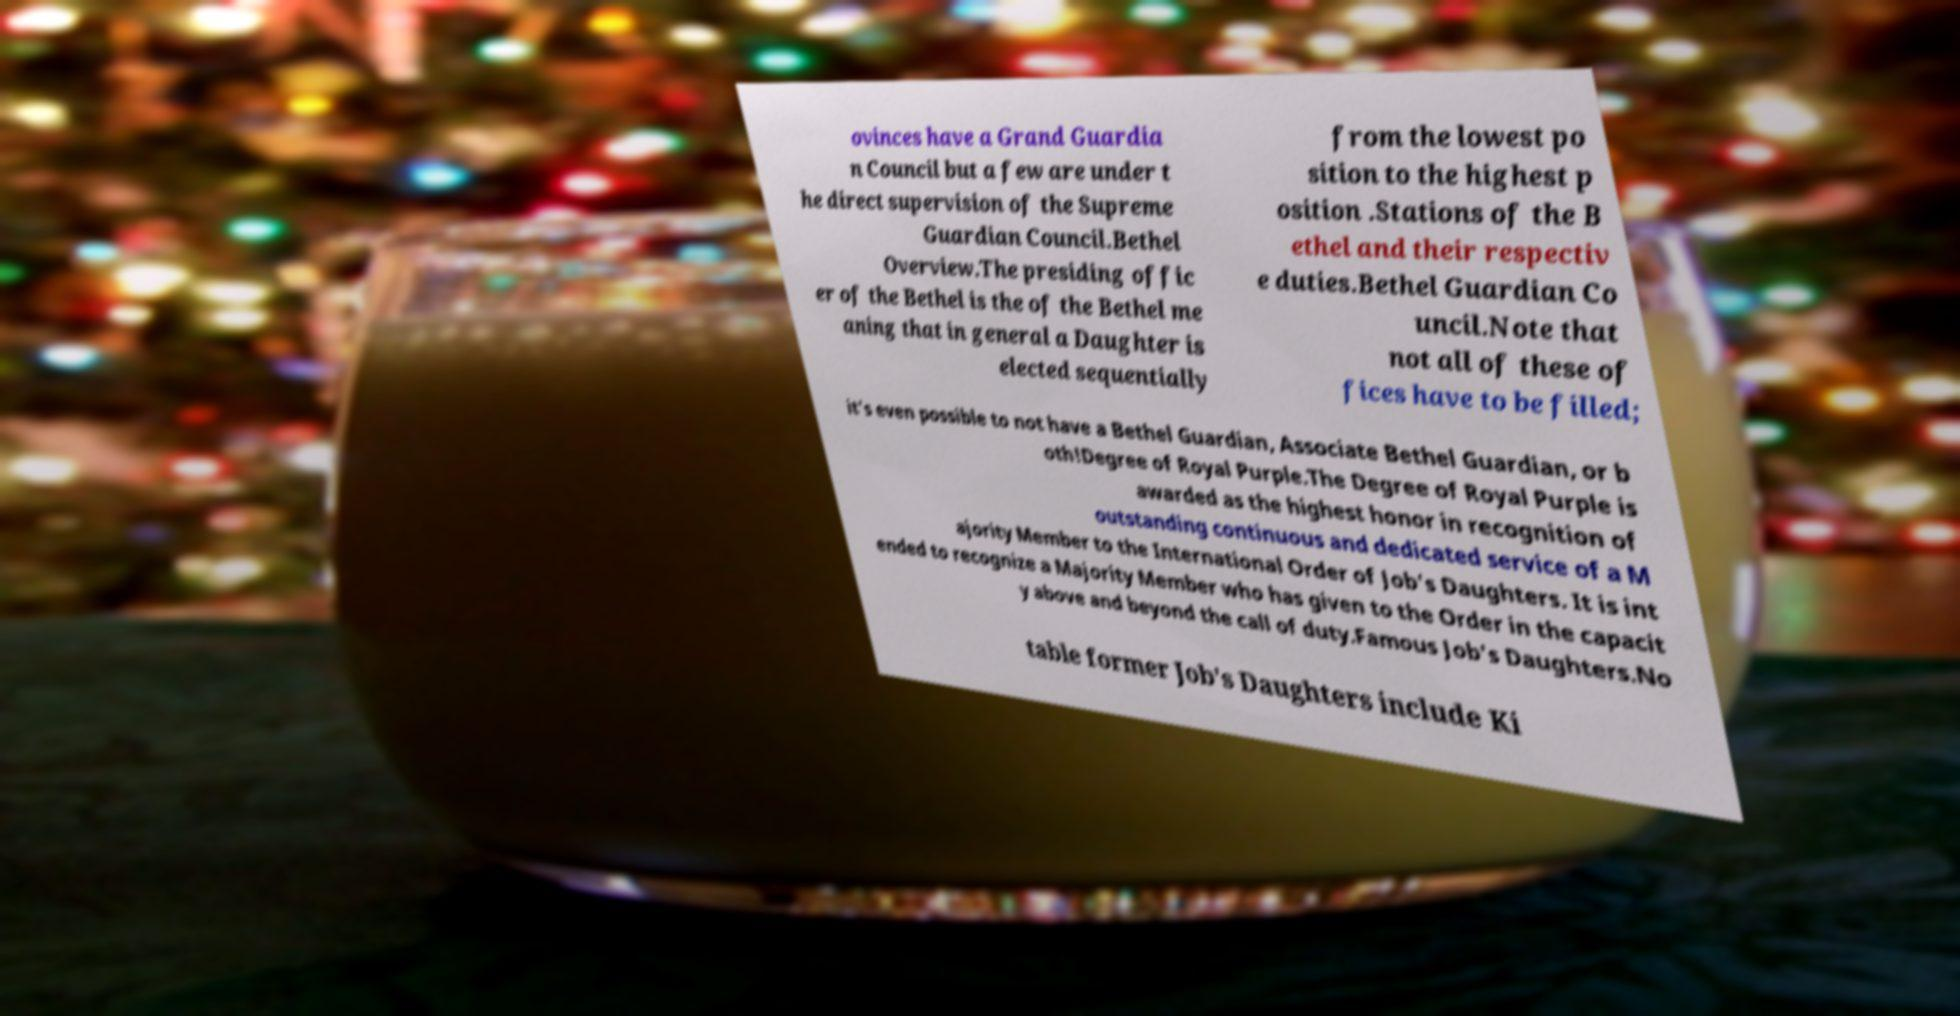For documentation purposes, I need the text within this image transcribed. Could you provide that? ovinces have a Grand Guardia n Council but a few are under t he direct supervision of the Supreme Guardian Council.Bethel Overview.The presiding offic er of the Bethel is the of the Bethel me aning that in general a Daughter is elected sequentially from the lowest po sition to the highest p osition .Stations of the B ethel and their respectiv e duties.Bethel Guardian Co uncil.Note that not all of these of fices have to be filled; it's even possible to not have a Bethel Guardian, Associate Bethel Guardian, or b oth!Degree of Royal Purple.The Degree of Royal Purple is awarded as the highest honor in recognition of outstanding continuous and dedicated service of a M ajority Member to the International Order of Job's Daughters. It is int ended to recognize a Majority Member who has given to the Order in the capacit y above and beyond the call of duty.Famous Job's Daughters.No table former Job's Daughters include Ki 